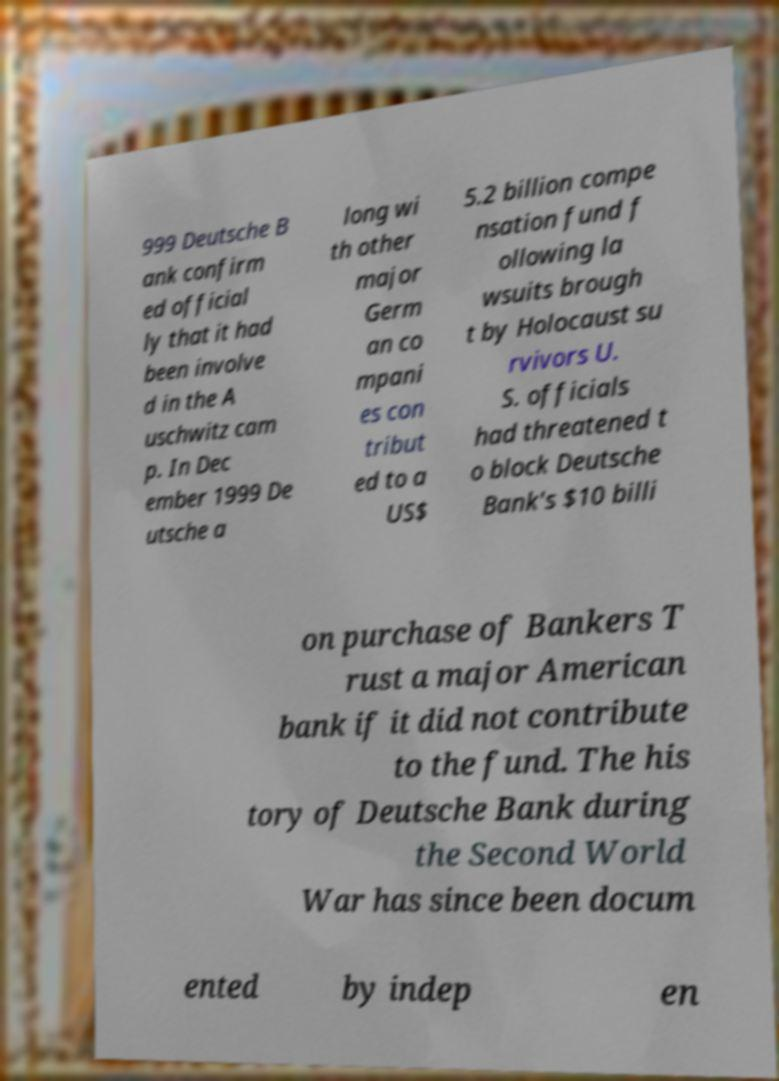Can you read and provide the text displayed in the image?This photo seems to have some interesting text. Can you extract and type it out for me? 999 Deutsche B ank confirm ed official ly that it had been involve d in the A uschwitz cam p. In Dec ember 1999 De utsche a long wi th other major Germ an co mpani es con tribut ed to a US$ 5.2 billion compe nsation fund f ollowing la wsuits brough t by Holocaust su rvivors U. S. officials had threatened t o block Deutsche Bank's $10 billi on purchase of Bankers T rust a major American bank if it did not contribute to the fund. The his tory of Deutsche Bank during the Second World War has since been docum ented by indep en 